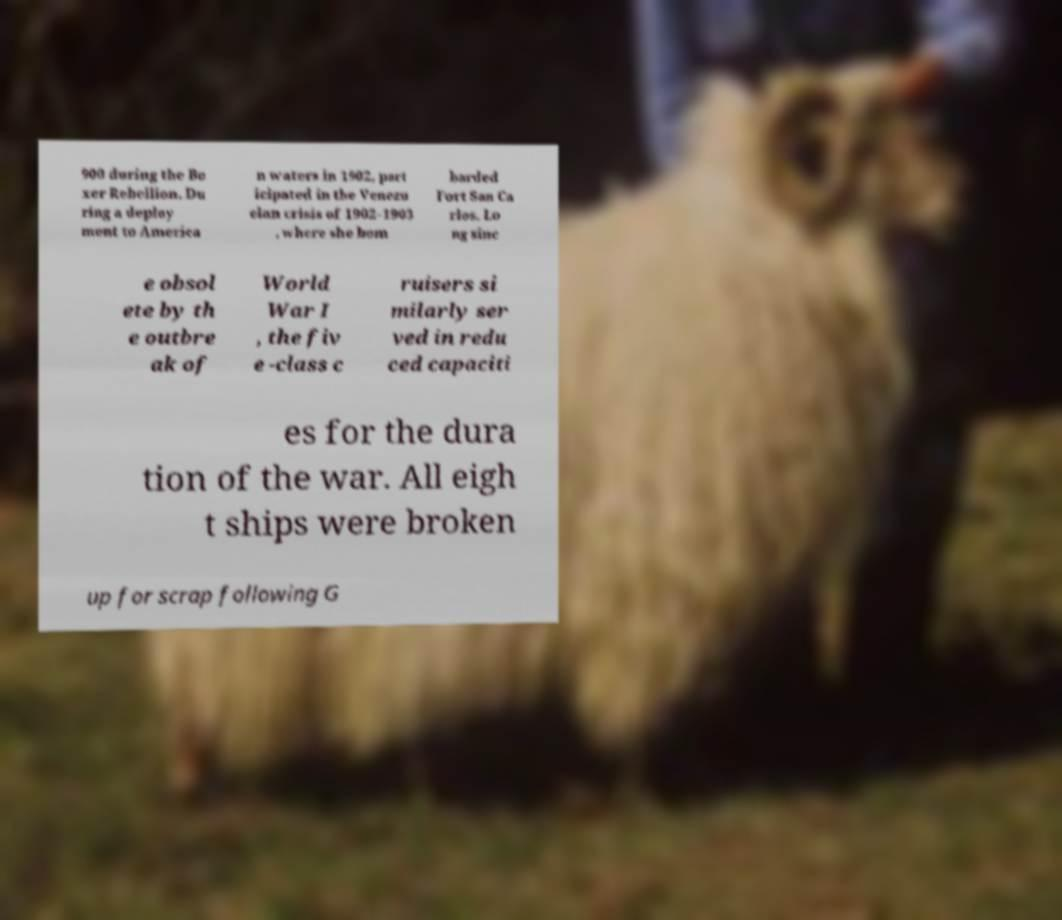For documentation purposes, I need the text within this image transcribed. Could you provide that? 900 during the Bo xer Rebellion. Du ring a deploy ment to America n waters in 1902, part icipated in the Venezu elan crisis of 1902–1903 , where she bom barded Fort San Ca rlos. Lo ng sinc e obsol ete by th e outbre ak of World War I , the fiv e -class c ruisers si milarly ser ved in redu ced capaciti es for the dura tion of the war. All eigh t ships were broken up for scrap following G 